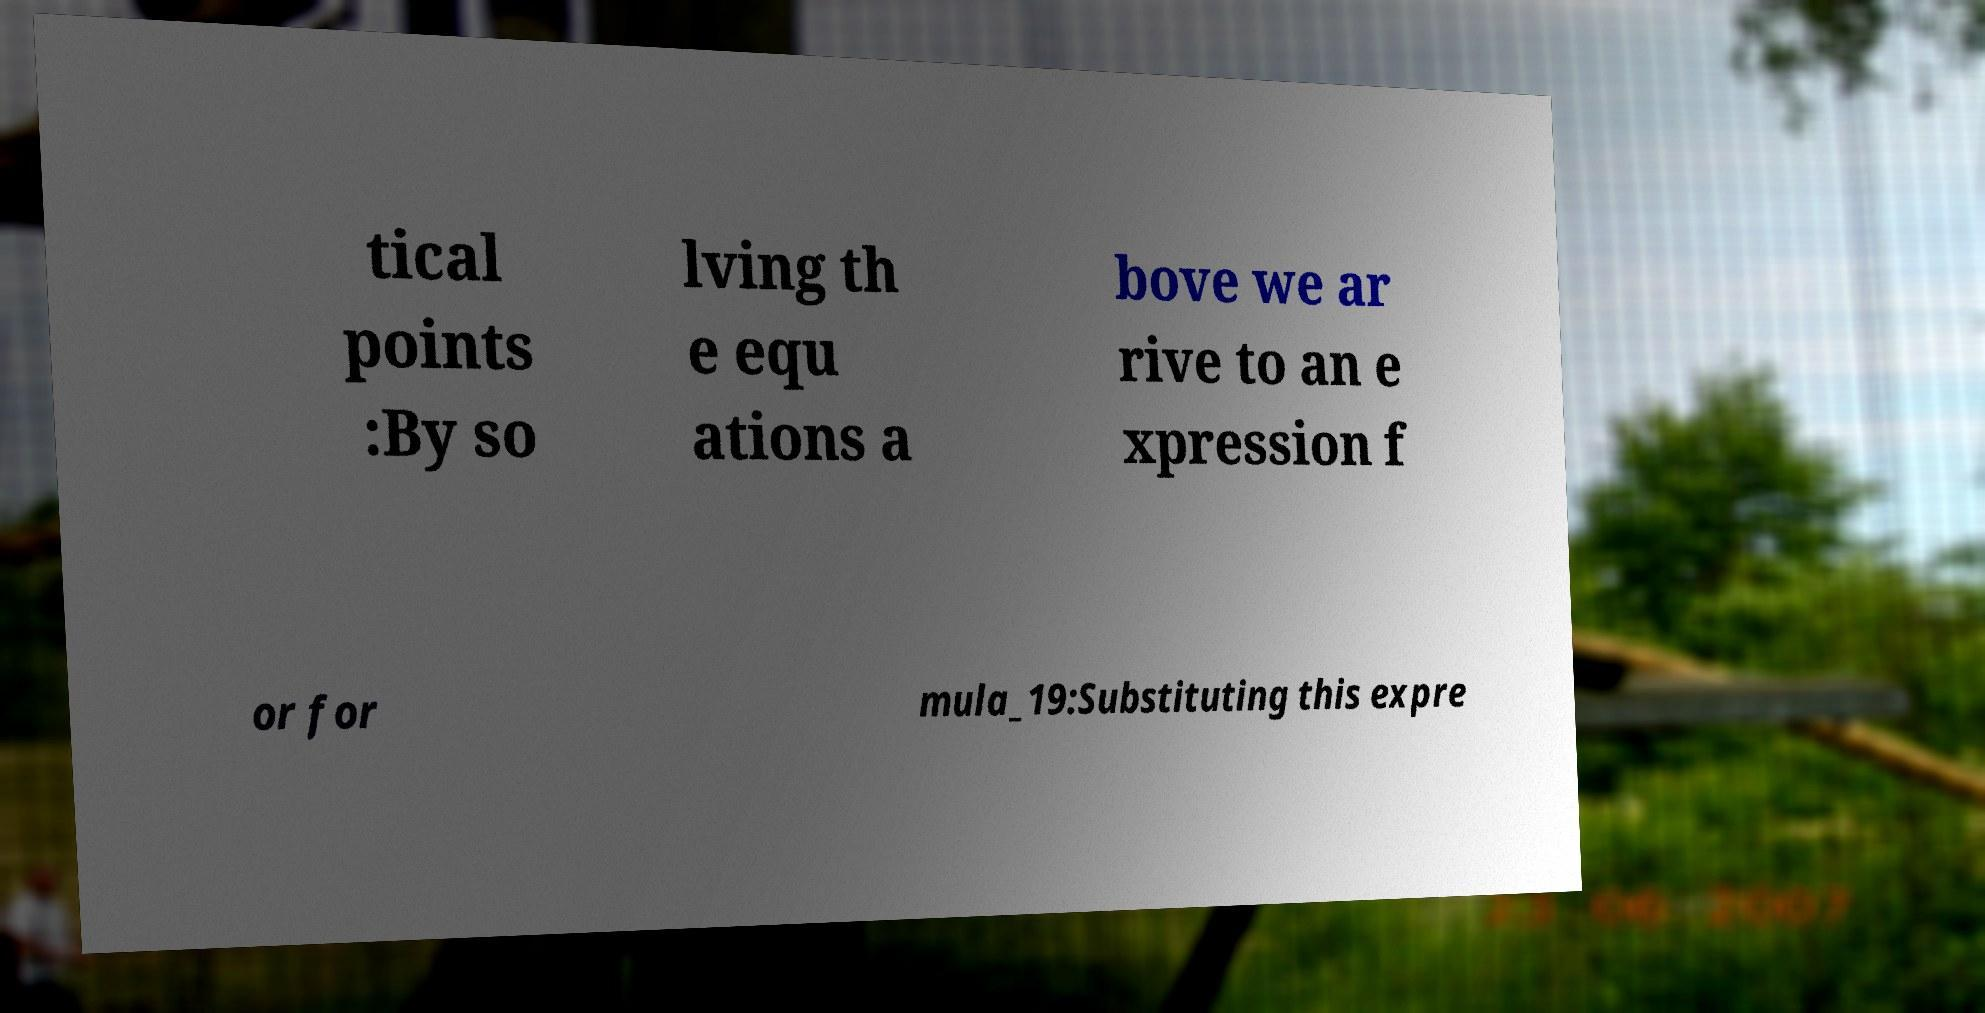Please identify and transcribe the text found in this image. tical points :By so lving th e equ ations a bove we ar rive to an e xpression f or for mula_19:Substituting this expre 